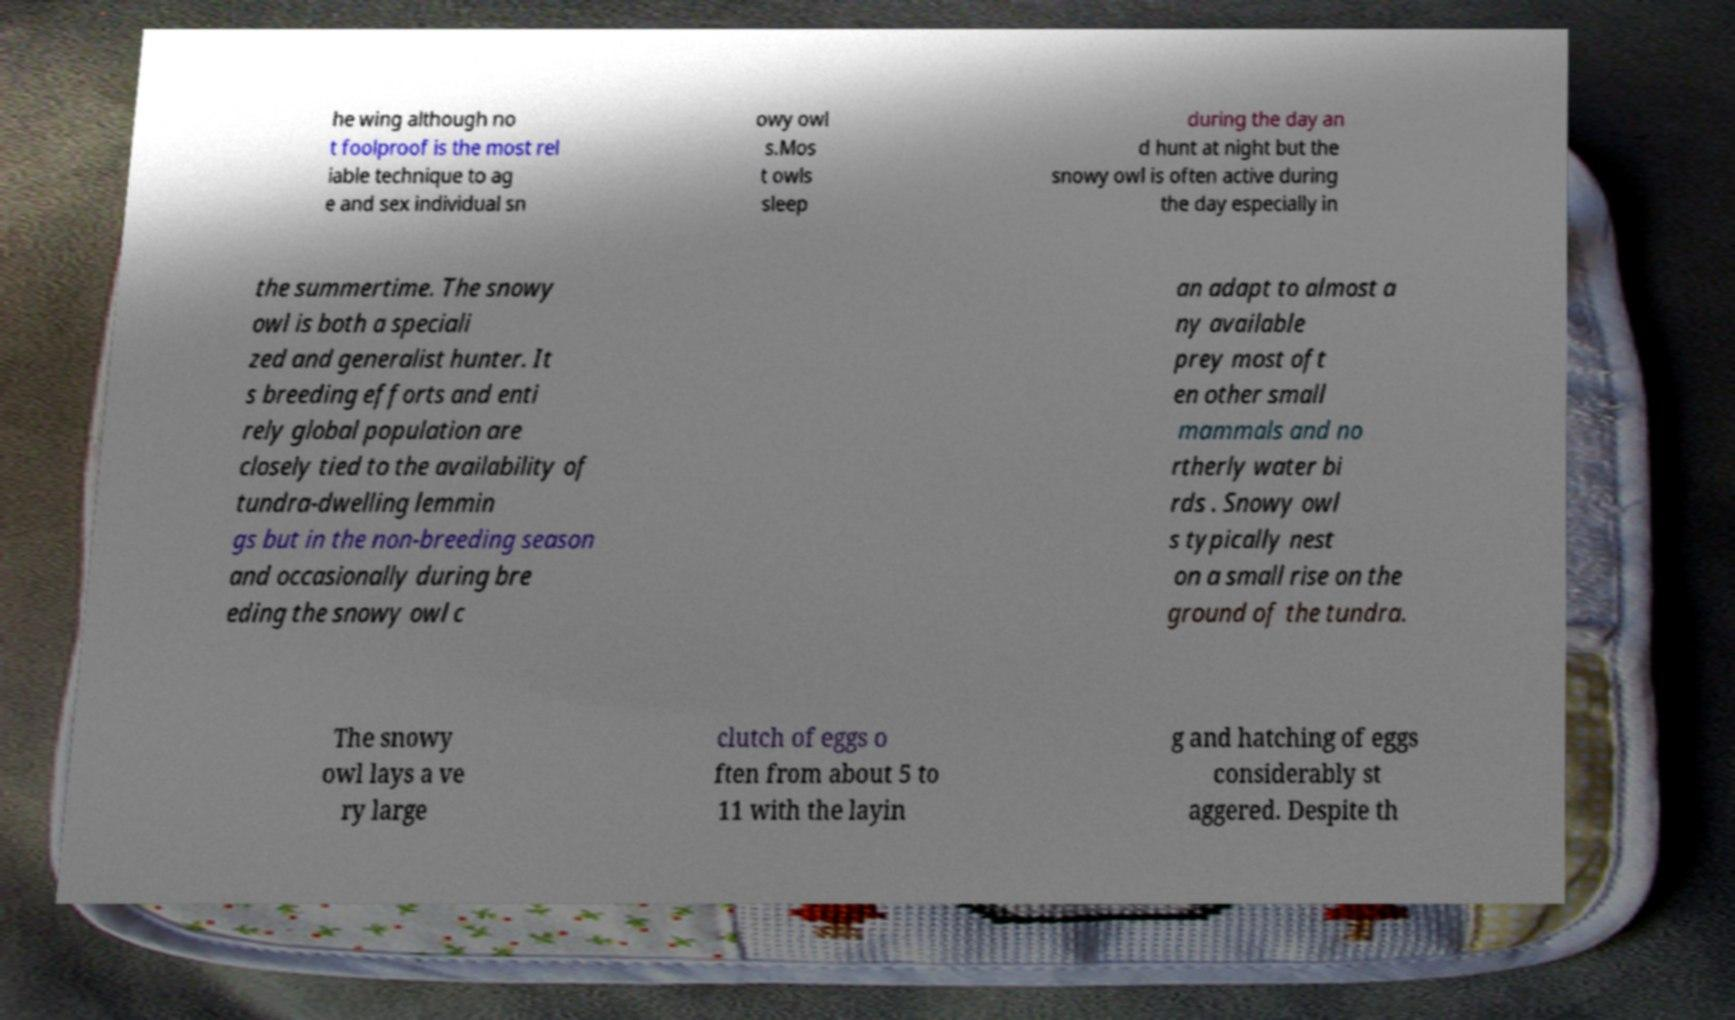For documentation purposes, I need the text within this image transcribed. Could you provide that? he wing although no t foolproof is the most rel iable technique to ag e and sex individual sn owy owl s.Mos t owls sleep during the day an d hunt at night but the snowy owl is often active during the day especially in the summertime. The snowy owl is both a speciali zed and generalist hunter. It s breeding efforts and enti rely global population are closely tied to the availability of tundra-dwelling lemmin gs but in the non-breeding season and occasionally during bre eding the snowy owl c an adapt to almost a ny available prey most oft en other small mammals and no rtherly water bi rds . Snowy owl s typically nest on a small rise on the ground of the tundra. The snowy owl lays a ve ry large clutch of eggs o ften from about 5 to 11 with the layin g and hatching of eggs considerably st aggered. Despite th 